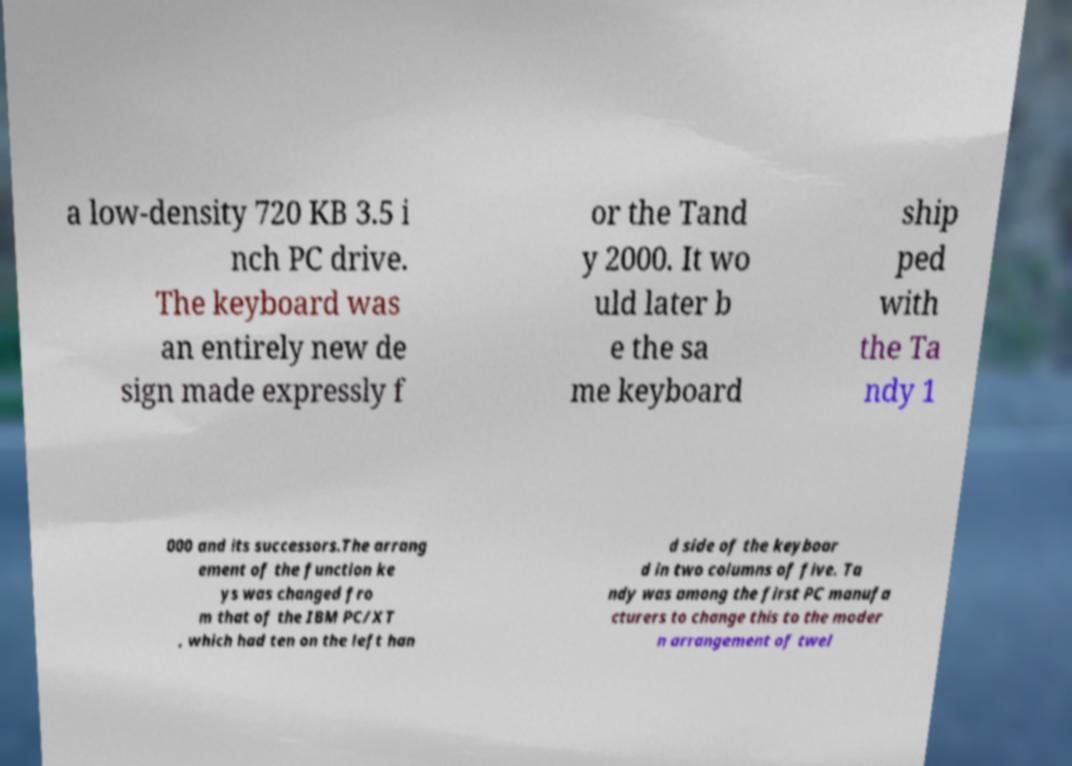Can you accurately transcribe the text from the provided image for me? a low-density 720 KB 3.5 i nch PC drive. The keyboard was an entirely new de sign made expressly f or the Tand y 2000. It wo uld later b e the sa me keyboard ship ped with the Ta ndy 1 000 and its successors.The arrang ement of the function ke ys was changed fro m that of the IBM PC/XT , which had ten on the left han d side of the keyboar d in two columns of five. Ta ndy was among the first PC manufa cturers to change this to the moder n arrangement of twel 